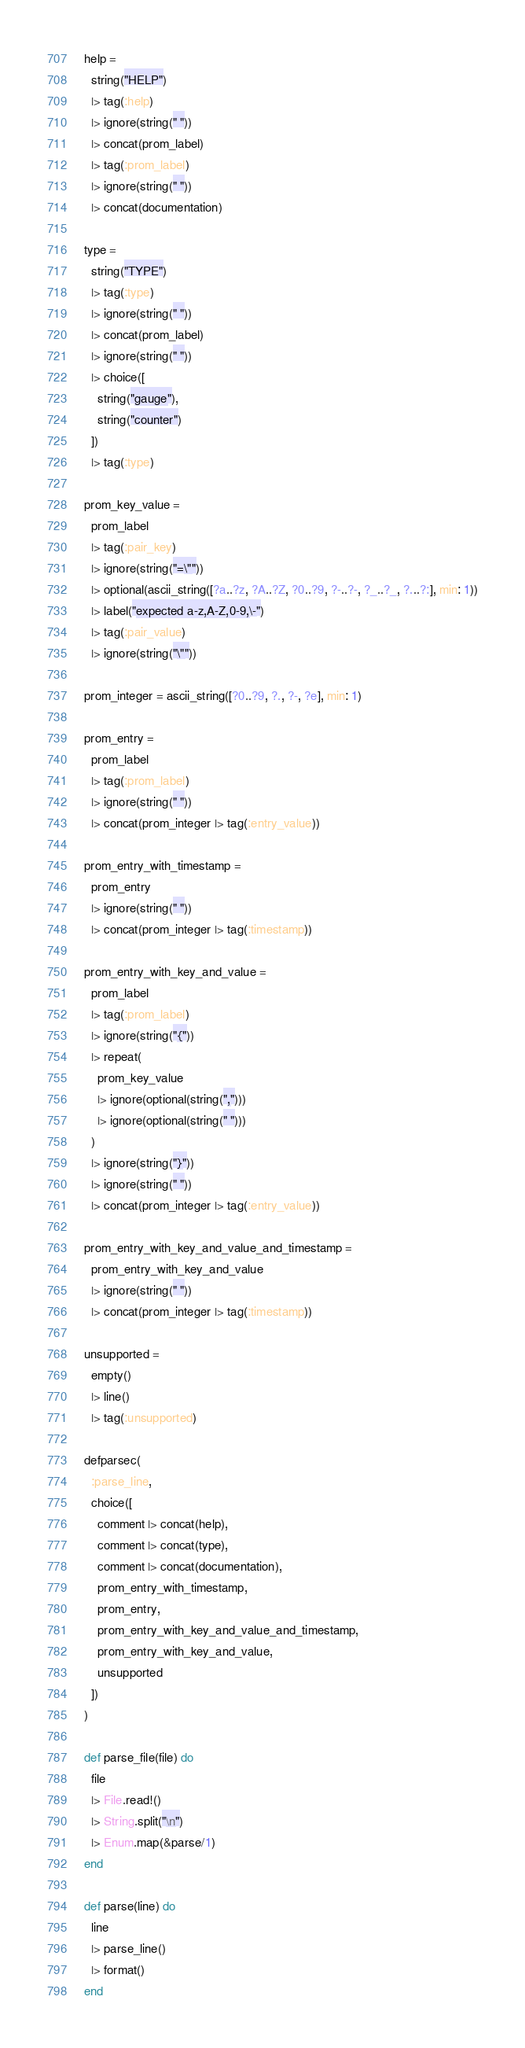<code> <loc_0><loc_0><loc_500><loc_500><_Elixir_>  help =
    string("HELP")
    |> tag(:help)
    |> ignore(string(" "))
    |> concat(prom_label)
    |> tag(:prom_label)
    |> ignore(string(" "))
    |> concat(documentation)

  type =
    string("TYPE")
    |> tag(:type)
    |> ignore(string(" "))
    |> concat(prom_label)
    |> ignore(string(" "))
    |> choice([
      string("gauge"),
      string("counter")
    ])
    |> tag(:type)

  prom_key_value =
    prom_label
    |> tag(:pair_key)
    |> ignore(string("=\""))
    |> optional(ascii_string([?a..?z, ?A..?Z, ?0..?9, ?-..?-, ?_..?_, ?...?:], min: 1))
    |> label("expected a-z,A-Z,0-9,\-")
    |> tag(:pair_value)
    |> ignore(string("\""))

  prom_integer = ascii_string([?0..?9, ?., ?-, ?e], min: 1)

  prom_entry =
    prom_label
    |> tag(:prom_label)
    |> ignore(string(" "))
    |> concat(prom_integer |> tag(:entry_value))

  prom_entry_with_timestamp =
    prom_entry
    |> ignore(string(" "))
    |> concat(prom_integer |> tag(:timestamp))

  prom_entry_with_key_and_value =
    prom_label
    |> tag(:prom_label)
    |> ignore(string("{"))
    |> repeat(
      prom_key_value
      |> ignore(optional(string(",")))
      |> ignore(optional(string(" ")))
    )
    |> ignore(string("}"))
    |> ignore(string(" "))
    |> concat(prom_integer |> tag(:entry_value))

  prom_entry_with_key_and_value_and_timestamp =
    prom_entry_with_key_and_value
    |> ignore(string(" "))
    |> concat(prom_integer |> tag(:timestamp))

  unsupported =
    empty()
    |> line()
    |> tag(:unsupported)

  defparsec(
    :parse_line,
    choice([
      comment |> concat(help),
      comment |> concat(type),
      comment |> concat(documentation),
      prom_entry_with_timestamp,
      prom_entry,
      prom_entry_with_key_and_value_and_timestamp,
      prom_entry_with_key_and_value,
      unsupported
    ])
  )

  def parse_file(file) do
    file
    |> File.read!()
    |> String.split("\n")
    |> Enum.map(&parse/1)
  end

  def parse(line) do
    line
    |> parse_line()
    |> format()
  end
</code> 